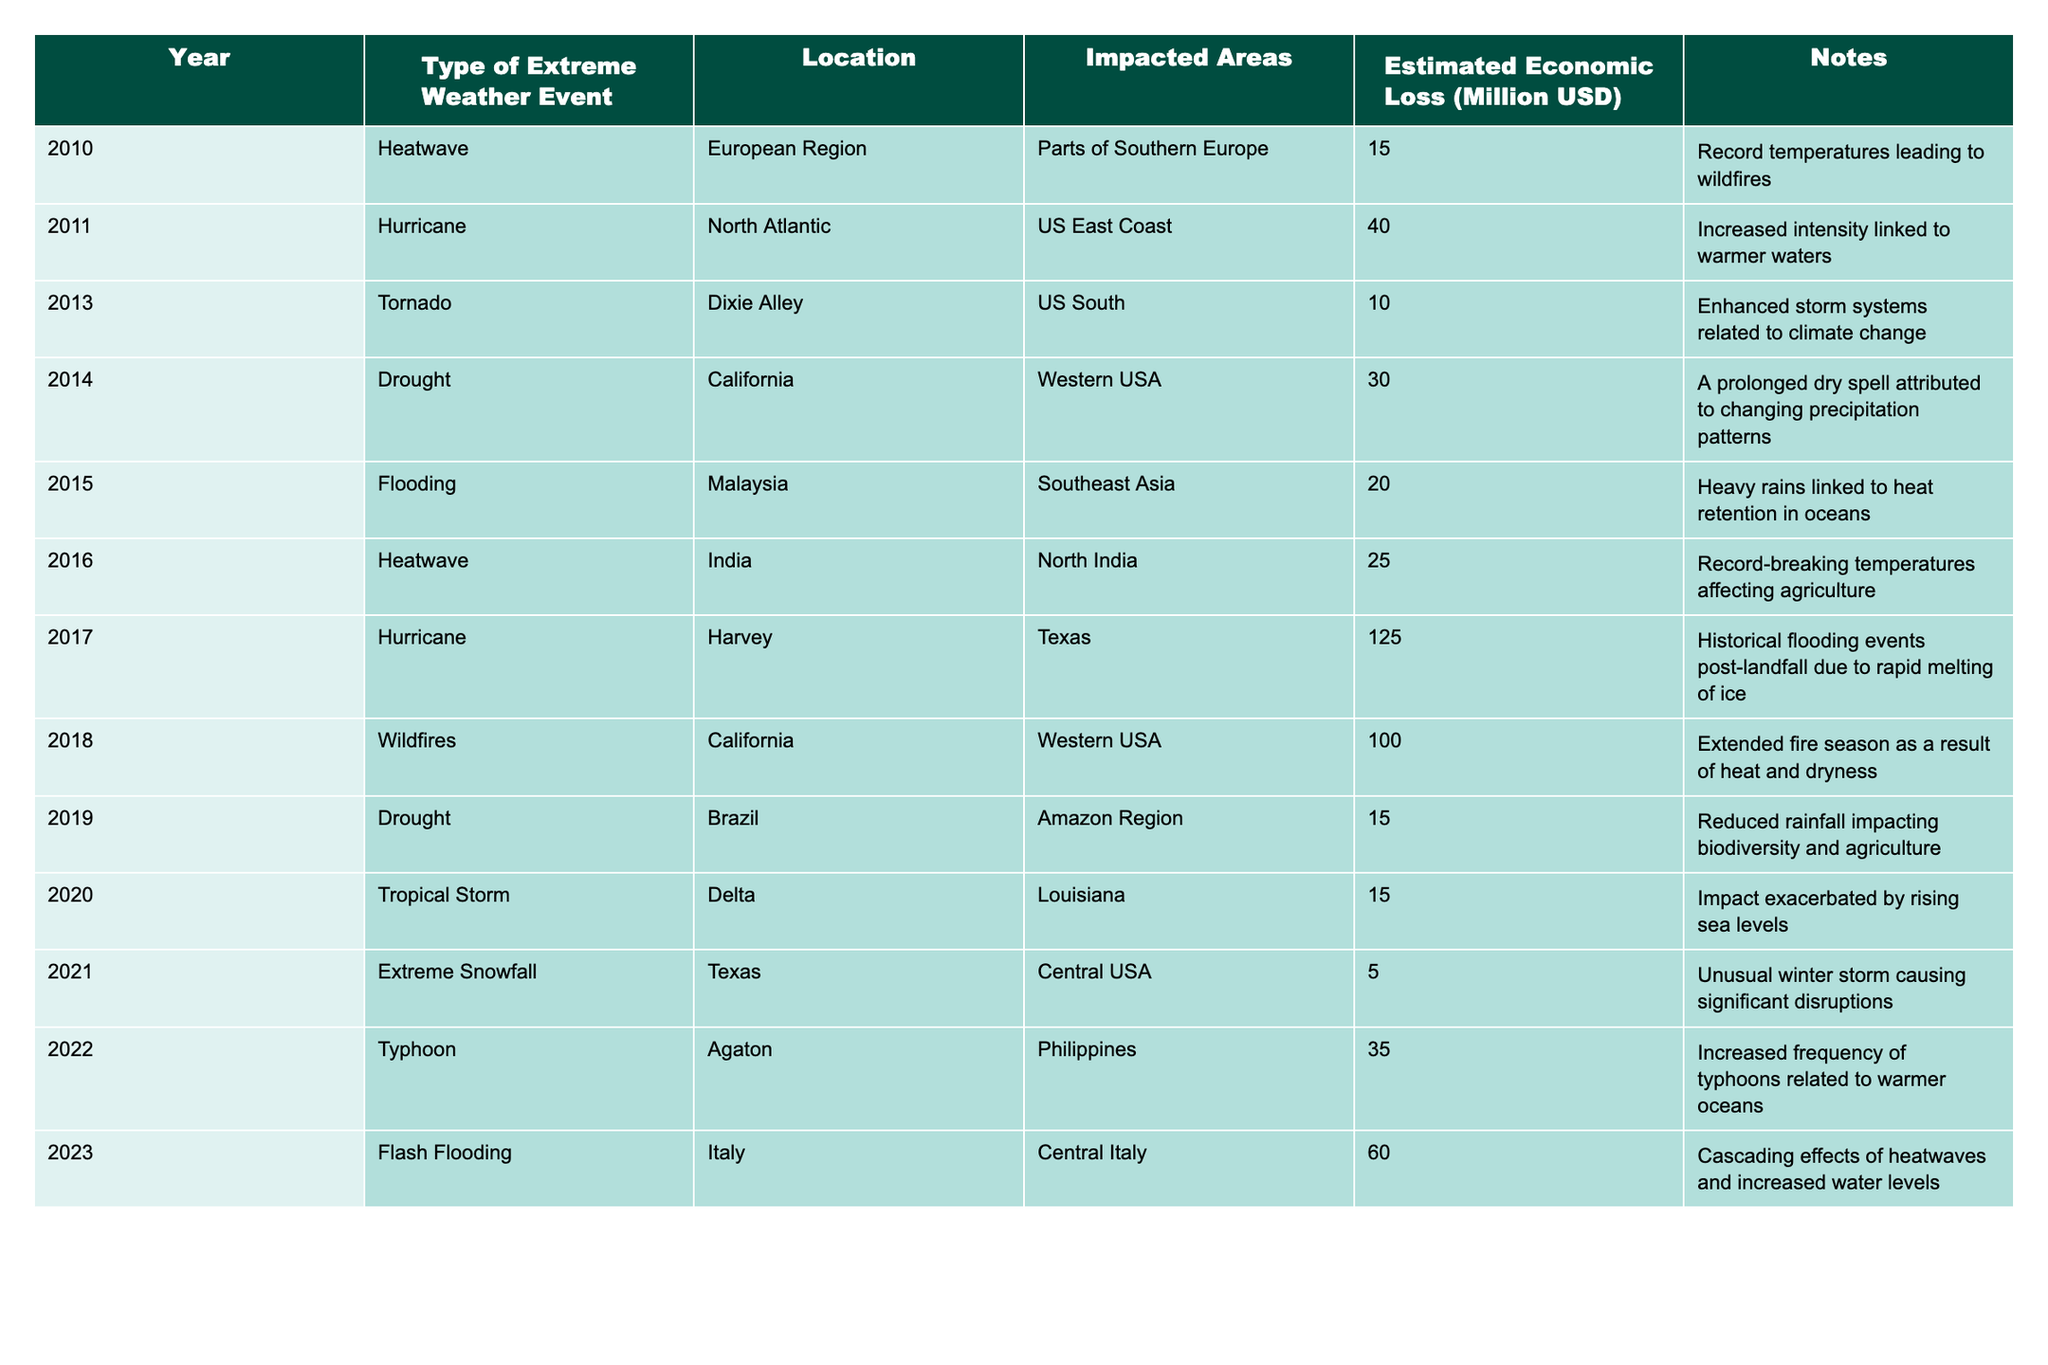What was the estimated economic loss from the 2017 Hurricane Harvey? The table lists the estimated economic loss for each event. For Hurricane Harvey in 2017, the estimated economic loss is 125 million USD.
Answer: 125 million USD Which year experienced the highest estimated economic loss due to extreme weather events? To find the year with the highest economic loss, we need to compare all values in the "Estimated Economic Loss" column. The highest value is 125 million USD in 2017 for Hurricane Harvey.
Answer: 2017 How many different types of extreme weather events are recorded in the table? Count the unique entries in the "Type of Extreme Weather Event" column, which lists 9 different types: Heatwave, Hurricane, Tornado, Drought, Flooding, Wildfires, Tropical Storm, Extreme Snowfall, and Typhoon.
Answer: 9 What was the total estimated economic loss from all extreme weather events in the dataset? To find the total economic loss, add all estimated losses: 15 + 40 + 10 + 30 + 20 + 25 + 125 + 100 + 15 + 15 + 5 + 35 + 60 = 515 million USD.
Answer: 515 million USD Was there any recorded extreme weather event in 2021? Reviewing the table, there is one event listed in 2021: Extreme Snowfall in Texas, confirming that there was an event that year.
Answer: Yes What relation can be inferred between the years of extreme weather events and their economic impact? Analyze the years and associated economic losses: High impact years like 2017 and 2018 show losses over 100 million USD, indicating that as events are recorded, the economic impact appears to increase, suggesting a potential correlation.
Answer: There appears to be a correlation Which region was most affected by extreme weather events according to the data? Reviewing the "Location" column shows repeated entries for California (wildfires and droughts in 2018 and 2014), indicating it is the most affected region.
Answer: California How many events resulted in economic losses of over 50 million USD? Check the estimates: Hurricane Harvey (125), Wildfires in California (100), and Flash Flooding in Italy (60) yield three instances of losses over 50 million USD.
Answer: 3 Were droughts recorded in more than one location between 2010 and 2023? The table indicates droughts in two locations: California in 2014 and Brazil in 2019, confirming that droughts occurred in multiple locations.
Answer: Yes In which year did Taiwan experience extreme weather events resulting in economic losses, according to the table? Inspecting the table reveals that there are no records for Taiwan; therefore, it did not experience any events according to the data provided.
Answer: No events recorded What is the economic loss attributed to the 2022 Typhoon Agaton? The estimated economic loss for Typhoon Agaton listed in the table is 35 million USD.
Answer: 35 million USD 